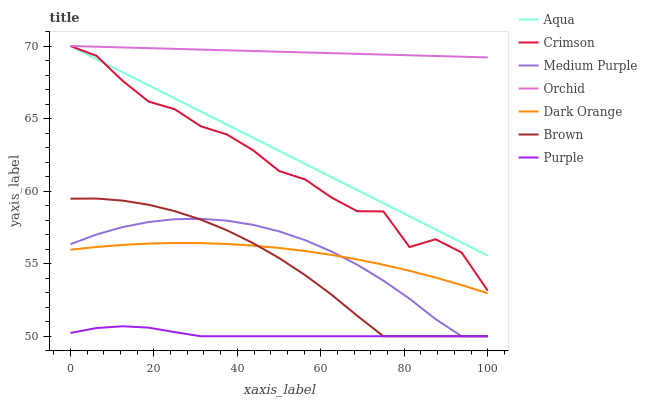Does Purple have the minimum area under the curve?
Answer yes or no. Yes. Does Orchid have the maximum area under the curve?
Answer yes or no. Yes. Does Dark Orange have the minimum area under the curve?
Answer yes or no. No. Does Dark Orange have the maximum area under the curve?
Answer yes or no. No. Is Aqua the smoothest?
Answer yes or no. Yes. Is Crimson the roughest?
Answer yes or no. Yes. Is Dark Orange the smoothest?
Answer yes or no. No. Is Dark Orange the roughest?
Answer yes or no. No. Does Brown have the lowest value?
Answer yes or no. Yes. Does Dark Orange have the lowest value?
Answer yes or no. No. Does Orchid have the highest value?
Answer yes or no. Yes. Does Dark Orange have the highest value?
Answer yes or no. No. Is Purple less than Orchid?
Answer yes or no. Yes. Is Crimson greater than Purple?
Answer yes or no. Yes. Does Purple intersect Medium Purple?
Answer yes or no. Yes. Is Purple less than Medium Purple?
Answer yes or no. No. Is Purple greater than Medium Purple?
Answer yes or no. No. Does Purple intersect Orchid?
Answer yes or no. No. 